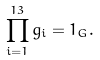<formula> <loc_0><loc_0><loc_500><loc_500>\prod _ { i = 1 } ^ { 1 3 } g _ { i } = { 1 } _ { G } .</formula> 